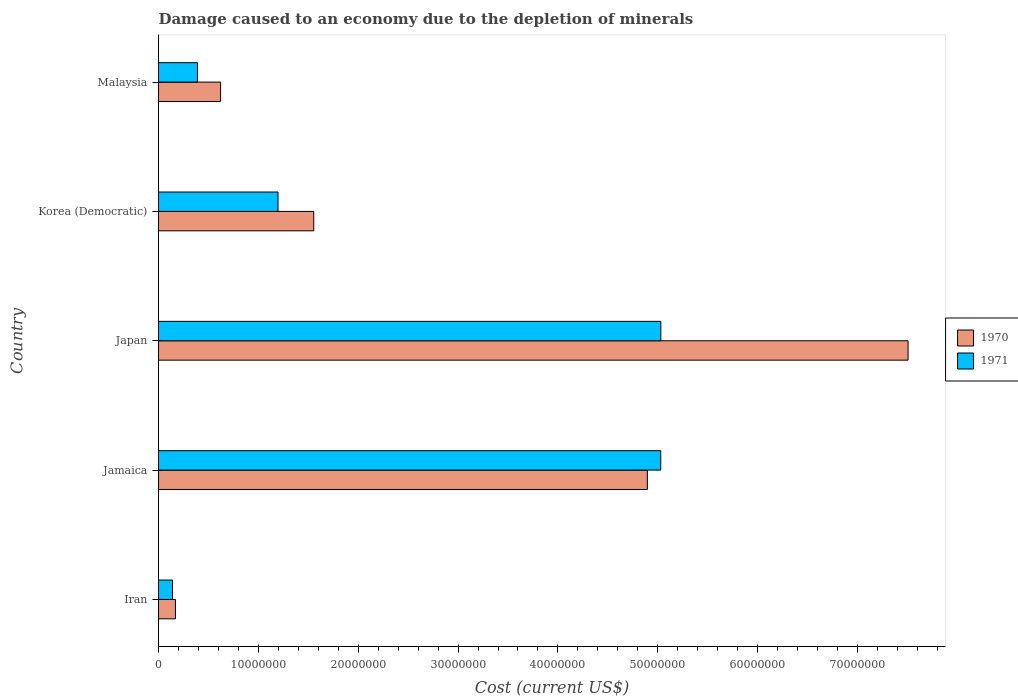How many different coloured bars are there?
Your answer should be very brief. 2. Are the number of bars per tick equal to the number of legend labels?
Your response must be concise. Yes. Are the number of bars on each tick of the Y-axis equal?
Offer a terse response. Yes. How many bars are there on the 1st tick from the top?
Ensure brevity in your answer.  2. How many bars are there on the 5th tick from the bottom?
Make the answer very short. 2. What is the label of the 4th group of bars from the top?
Offer a terse response. Jamaica. What is the cost of damage caused due to the depletion of minerals in 1970 in Iran?
Offer a terse response. 1.70e+06. Across all countries, what is the maximum cost of damage caused due to the depletion of minerals in 1971?
Offer a terse response. 5.03e+07. Across all countries, what is the minimum cost of damage caused due to the depletion of minerals in 1971?
Offer a very short reply. 1.40e+06. In which country was the cost of damage caused due to the depletion of minerals in 1971 maximum?
Make the answer very short. Japan. In which country was the cost of damage caused due to the depletion of minerals in 1970 minimum?
Your response must be concise. Iran. What is the total cost of damage caused due to the depletion of minerals in 1971 in the graph?
Keep it short and to the point. 1.18e+08. What is the difference between the cost of damage caused due to the depletion of minerals in 1971 in Iran and that in Korea (Democratic)?
Your answer should be very brief. -1.06e+07. What is the difference between the cost of damage caused due to the depletion of minerals in 1970 in Jamaica and the cost of damage caused due to the depletion of minerals in 1971 in Malaysia?
Provide a short and direct response. 4.51e+07. What is the average cost of damage caused due to the depletion of minerals in 1970 per country?
Your answer should be compact. 2.95e+07. What is the difference between the cost of damage caused due to the depletion of minerals in 1971 and cost of damage caused due to the depletion of minerals in 1970 in Korea (Democratic)?
Ensure brevity in your answer.  -3.58e+06. What is the ratio of the cost of damage caused due to the depletion of minerals in 1971 in Jamaica to that in Korea (Democratic)?
Give a very brief answer. 4.2. Is the cost of damage caused due to the depletion of minerals in 1971 in Iran less than that in Jamaica?
Offer a very short reply. Yes. What is the difference between the highest and the second highest cost of damage caused due to the depletion of minerals in 1970?
Provide a short and direct response. 2.61e+07. What is the difference between the highest and the lowest cost of damage caused due to the depletion of minerals in 1970?
Offer a very short reply. 7.34e+07. What does the 1st bar from the top in Malaysia represents?
Your answer should be compact. 1971. How many bars are there?
Provide a succinct answer. 10. Are all the bars in the graph horizontal?
Provide a short and direct response. Yes. How many countries are there in the graph?
Your answer should be very brief. 5. What is the difference between two consecutive major ticks on the X-axis?
Offer a very short reply. 1.00e+07. Does the graph contain grids?
Offer a very short reply. No. Where does the legend appear in the graph?
Your answer should be compact. Center right. How many legend labels are there?
Your answer should be very brief. 2. What is the title of the graph?
Provide a short and direct response. Damage caused to an economy due to the depletion of minerals. Does "2015" appear as one of the legend labels in the graph?
Your response must be concise. No. What is the label or title of the X-axis?
Your answer should be compact. Cost (current US$). What is the Cost (current US$) in 1970 in Iran?
Offer a terse response. 1.70e+06. What is the Cost (current US$) of 1971 in Iran?
Keep it short and to the point. 1.40e+06. What is the Cost (current US$) of 1970 in Jamaica?
Offer a very short reply. 4.90e+07. What is the Cost (current US$) of 1971 in Jamaica?
Provide a short and direct response. 5.03e+07. What is the Cost (current US$) of 1970 in Japan?
Offer a terse response. 7.51e+07. What is the Cost (current US$) of 1971 in Japan?
Your answer should be very brief. 5.03e+07. What is the Cost (current US$) of 1970 in Korea (Democratic)?
Offer a very short reply. 1.55e+07. What is the Cost (current US$) in 1971 in Korea (Democratic)?
Offer a very short reply. 1.20e+07. What is the Cost (current US$) in 1970 in Malaysia?
Ensure brevity in your answer.  6.22e+06. What is the Cost (current US$) in 1971 in Malaysia?
Keep it short and to the point. 3.90e+06. Across all countries, what is the maximum Cost (current US$) in 1970?
Offer a very short reply. 7.51e+07. Across all countries, what is the maximum Cost (current US$) of 1971?
Give a very brief answer. 5.03e+07. Across all countries, what is the minimum Cost (current US$) in 1970?
Your answer should be compact. 1.70e+06. Across all countries, what is the minimum Cost (current US$) of 1971?
Your response must be concise. 1.40e+06. What is the total Cost (current US$) of 1970 in the graph?
Give a very brief answer. 1.47e+08. What is the total Cost (current US$) of 1971 in the graph?
Provide a short and direct response. 1.18e+08. What is the difference between the Cost (current US$) in 1970 in Iran and that in Jamaica?
Offer a very short reply. -4.73e+07. What is the difference between the Cost (current US$) in 1971 in Iran and that in Jamaica?
Give a very brief answer. -4.89e+07. What is the difference between the Cost (current US$) of 1970 in Iran and that in Japan?
Provide a succinct answer. -7.34e+07. What is the difference between the Cost (current US$) of 1971 in Iran and that in Japan?
Ensure brevity in your answer.  -4.89e+07. What is the difference between the Cost (current US$) in 1970 in Iran and that in Korea (Democratic)?
Your answer should be compact. -1.38e+07. What is the difference between the Cost (current US$) in 1971 in Iran and that in Korea (Democratic)?
Make the answer very short. -1.06e+07. What is the difference between the Cost (current US$) in 1970 in Iran and that in Malaysia?
Offer a very short reply. -4.52e+06. What is the difference between the Cost (current US$) in 1971 in Iran and that in Malaysia?
Provide a short and direct response. -2.51e+06. What is the difference between the Cost (current US$) in 1970 in Jamaica and that in Japan?
Ensure brevity in your answer.  -2.61e+07. What is the difference between the Cost (current US$) of 1971 in Jamaica and that in Japan?
Offer a very short reply. -1.04e+04. What is the difference between the Cost (current US$) in 1970 in Jamaica and that in Korea (Democratic)?
Your answer should be compact. 3.34e+07. What is the difference between the Cost (current US$) in 1971 in Jamaica and that in Korea (Democratic)?
Your answer should be compact. 3.83e+07. What is the difference between the Cost (current US$) in 1970 in Jamaica and that in Malaysia?
Ensure brevity in your answer.  4.27e+07. What is the difference between the Cost (current US$) of 1971 in Jamaica and that in Malaysia?
Provide a short and direct response. 4.64e+07. What is the difference between the Cost (current US$) in 1970 in Japan and that in Korea (Democratic)?
Make the answer very short. 5.95e+07. What is the difference between the Cost (current US$) of 1971 in Japan and that in Korea (Democratic)?
Ensure brevity in your answer.  3.83e+07. What is the difference between the Cost (current US$) of 1970 in Japan and that in Malaysia?
Provide a succinct answer. 6.88e+07. What is the difference between the Cost (current US$) of 1971 in Japan and that in Malaysia?
Make the answer very short. 4.64e+07. What is the difference between the Cost (current US$) in 1970 in Korea (Democratic) and that in Malaysia?
Your response must be concise. 9.33e+06. What is the difference between the Cost (current US$) in 1971 in Korea (Democratic) and that in Malaysia?
Provide a succinct answer. 8.06e+06. What is the difference between the Cost (current US$) of 1970 in Iran and the Cost (current US$) of 1971 in Jamaica?
Provide a succinct answer. -4.86e+07. What is the difference between the Cost (current US$) of 1970 in Iran and the Cost (current US$) of 1971 in Japan?
Make the answer very short. -4.86e+07. What is the difference between the Cost (current US$) in 1970 in Iran and the Cost (current US$) in 1971 in Korea (Democratic)?
Your answer should be compact. -1.03e+07. What is the difference between the Cost (current US$) in 1970 in Iran and the Cost (current US$) in 1971 in Malaysia?
Offer a terse response. -2.21e+06. What is the difference between the Cost (current US$) in 1970 in Jamaica and the Cost (current US$) in 1971 in Japan?
Offer a very short reply. -1.35e+06. What is the difference between the Cost (current US$) in 1970 in Jamaica and the Cost (current US$) in 1971 in Korea (Democratic)?
Give a very brief answer. 3.70e+07. What is the difference between the Cost (current US$) in 1970 in Jamaica and the Cost (current US$) in 1971 in Malaysia?
Ensure brevity in your answer.  4.51e+07. What is the difference between the Cost (current US$) of 1970 in Japan and the Cost (current US$) of 1971 in Korea (Democratic)?
Your answer should be compact. 6.31e+07. What is the difference between the Cost (current US$) in 1970 in Japan and the Cost (current US$) in 1971 in Malaysia?
Offer a very short reply. 7.12e+07. What is the difference between the Cost (current US$) in 1970 in Korea (Democratic) and the Cost (current US$) in 1971 in Malaysia?
Provide a short and direct response. 1.16e+07. What is the average Cost (current US$) in 1970 per country?
Your response must be concise. 2.95e+07. What is the average Cost (current US$) of 1971 per country?
Give a very brief answer. 2.36e+07. What is the difference between the Cost (current US$) of 1970 and Cost (current US$) of 1971 in Iran?
Offer a very short reply. 2.97e+05. What is the difference between the Cost (current US$) of 1970 and Cost (current US$) of 1971 in Jamaica?
Offer a terse response. -1.34e+06. What is the difference between the Cost (current US$) of 1970 and Cost (current US$) of 1971 in Japan?
Provide a short and direct response. 2.48e+07. What is the difference between the Cost (current US$) of 1970 and Cost (current US$) of 1971 in Korea (Democratic)?
Your response must be concise. 3.58e+06. What is the difference between the Cost (current US$) in 1970 and Cost (current US$) in 1971 in Malaysia?
Make the answer very short. 2.31e+06. What is the ratio of the Cost (current US$) of 1970 in Iran to that in Jamaica?
Provide a succinct answer. 0.03. What is the ratio of the Cost (current US$) of 1971 in Iran to that in Jamaica?
Ensure brevity in your answer.  0.03. What is the ratio of the Cost (current US$) of 1970 in Iran to that in Japan?
Make the answer very short. 0.02. What is the ratio of the Cost (current US$) in 1971 in Iran to that in Japan?
Provide a succinct answer. 0.03. What is the ratio of the Cost (current US$) of 1970 in Iran to that in Korea (Democratic)?
Keep it short and to the point. 0.11. What is the ratio of the Cost (current US$) of 1971 in Iran to that in Korea (Democratic)?
Offer a terse response. 0.12. What is the ratio of the Cost (current US$) in 1970 in Iran to that in Malaysia?
Provide a succinct answer. 0.27. What is the ratio of the Cost (current US$) in 1971 in Iran to that in Malaysia?
Ensure brevity in your answer.  0.36. What is the ratio of the Cost (current US$) in 1970 in Jamaica to that in Japan?
Give a very brief answer. 0.65. What is the ratio of the Cost (current US$) of 1971 in Jamaica to that in Japan?
Ensure brevity in your answer.  1. What is the ratio of the Cost (current US$) in 1970 in Jamaica to that in Korea (Democratic)?
Make the answer very short. 3.15. What is the ratio of the Cost (current US$) in 1971 in Jamaica to that in Korea (Democratic)?
Your answer should be compact. 4.2. What is the ratio of the Cost (current US$) in 1970 in Jamaica to that in Malaysia?
Provide a short and direct response. 7.87. What is the ratio of the Cost (current US$) of 1971 in Jamaica to that in Malaysia?
Your answer should be compact. 12.88. What is the ratio of the Cost (current US$) of 1970 in Japan to that in Korea (Democratic)?
Your response must be concise. 4.83. What is the ratio of the Cost (current US$) in 1971 in Japan to that in Korea (Democratic)?
Offer a very short reply. 4.2. What is the ratio of the Cost (current US$) of 1970 in Japan to that in Malaysia?
Your response must be concise. 12.07. What is the ratio of the Cost (current US$) of 1971 in Japan to that in Malaysia?
Offer a very short reply. 12.88. What is the ratio of the Cost (current US$) of 1970 in Korea (Democratic) to that in Malaysia?
Keep it short and to the point. 2.5. What is the ratio of the Cost (current US$) of 1971 in Korea (Democratic) to that in Malaysia?
Ensure brevity in your answer.  3.07. What is the difference between the highest and the second highest Cost (current US$) in 1970?
Your answer should be very brief. 2.61e+07. What is the difference between the highest and the second highest Cost (current US$) of 1971?
Offer a very short reply. 1.04e+04. What is the difference between the highest and the lowest Cost (current US$) in 1970?
Ensure brevity in your answer.  7.34e+07. What is the difference between the highest and the lowest Cost (current US$) in 1971?
Your answer should be very brief. 4.89e+07. 